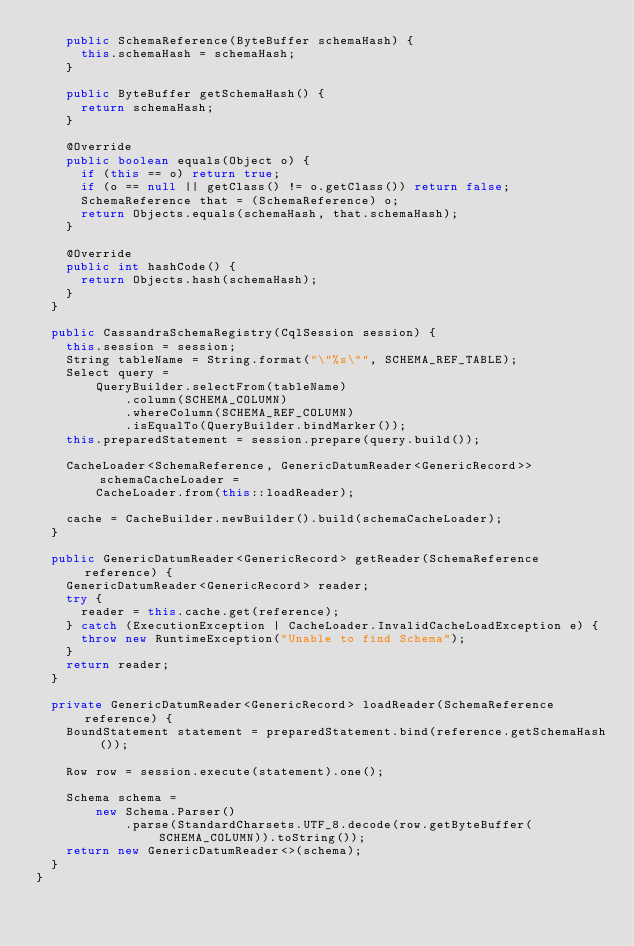<code> <loc_0><loc_0><loc_500><loc_500><_Java_>    public SchemaReference(ByteBuffer schemaHash) {
      this.schemaHash = schemaHash;
    }

    public ByteBuffer getSchemaHash() {
      return schemaHash;
    }

    @Override
    public boolean equals(Object o) {
      if (this == o) return true;
      if (o == null || getClass() != o.getClass()) return false;
      SchemaReference that = (SchemaReference) o;
      return Objects.equals(schemaHash, that.schemaHash);
    }

    @Override
    public int hashCode() {
      return Objects.hash(schemaHash);
    }
  }

  public CassandraSchemaRegistry(CqlSession session) {
    this.session = session;
    String tableName = String.format("\"%s\"", SCHEMA_REF_TABLE);
    Select query =
        QueryBuilder.selectFrom(tableName)
            .column(SCHEMA_COLUMN)
            .whereColumn(SCHEMA_REF_COLUMN)
            .isEqualTo(QueryBuilder.bindMarker());
    this.preparedStatement = session.prepare(query.build());

    CacheLoader<SchemaReference, GenericDatumReader<GenericRecord>> schemaCacheLoader =
        CacheLoader.from(this::loadReader);

    cache = CacheBuilder.newBuilder().build(schemaCacheLoader);
  }

  public GenericDatumReader<GenericRecord> getReader(SchemaReference reference) {
    GenericDatumReader<GenericRecord> reader;
    try {
      reader = this.cache.get(reference);
    } catch (ExecutionException | CacheLoader.InvalidCacheLoadException e) {
      throw new RuntimeException("Unable to find Schema");
    }
    return reader;
  }

  private GenericDatumReader<GenericRecord> loadReader(SchemaReference reference) {
    BoundStatement statement = preparedStatement.bind(reference.getSchemaHash());

    Row row = session.execute(statement).one();

    Schema schema =
        new Schema.Parser()
            .parse(StandardCharsets.UTF_8.decode(row.getByteBuffer(SCHEMA_COLUMN)).toString());
    return new GenericDatumReader<>(schema);
  }
}
</code> 